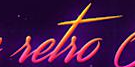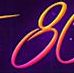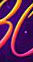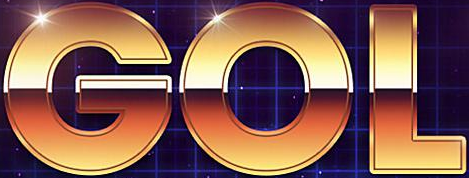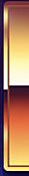What words are shown in these images in order, separated by a semicolon? setso; 8; #; GOL; # 